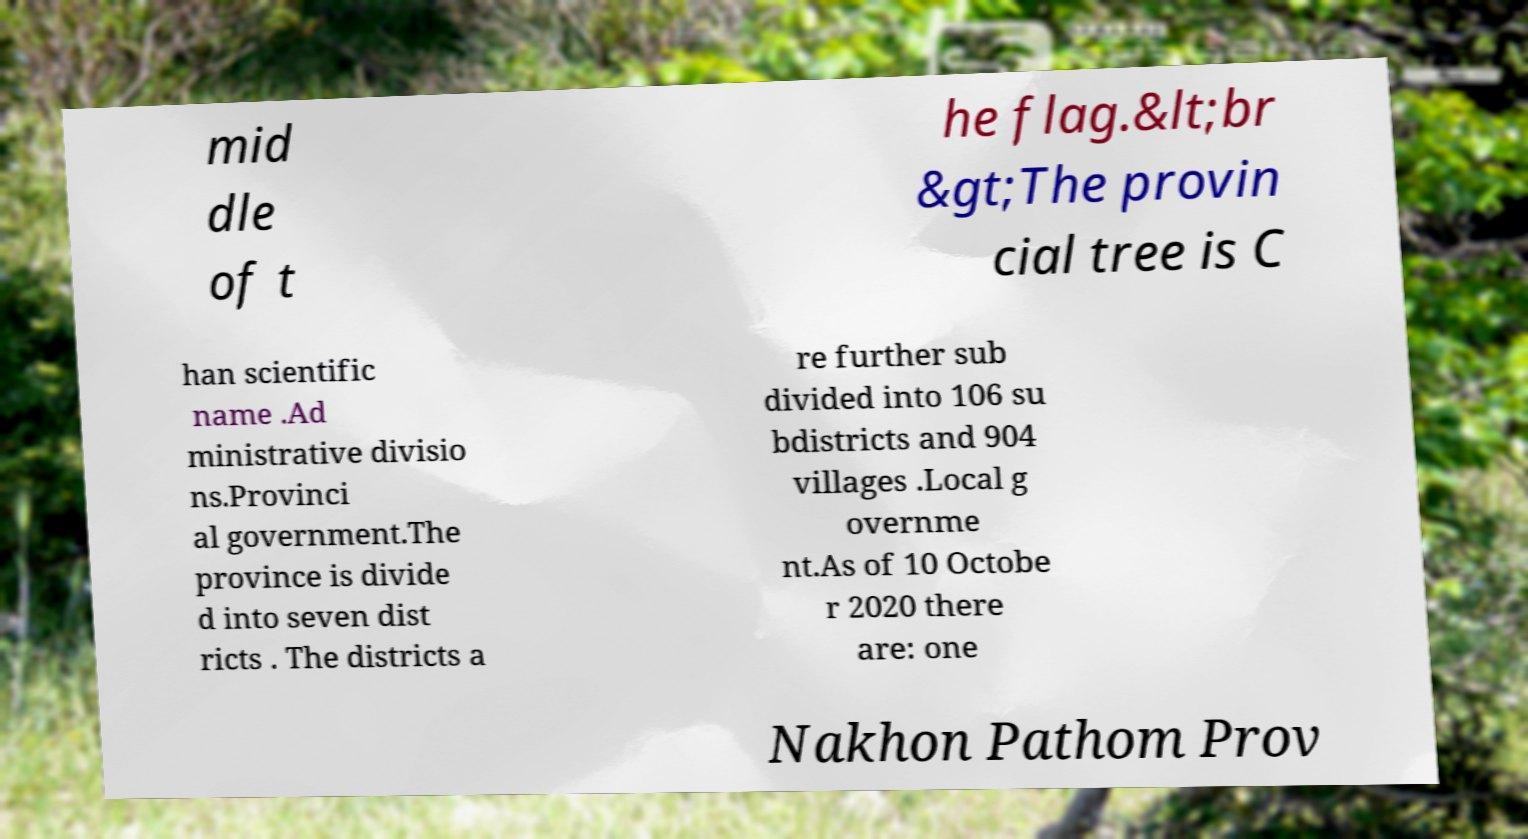What messages or text are displayed in this image? I need them in a readable, typed format. mid dle of t he flag.&lt;br &gt;The provin cial tree is C han scientific name .Ad ministrative divisio ns.Provinci al government.The province is divide d into seven dist ricts . The districts a re further sub divided into 106 su bdistricts and 904 villages .Local g overnme nt.As of 10 Octobe r 2020 there are: one Nakhon Pathom Prov 